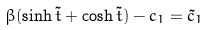<formula> <loc_0><loc_0><loc_500><loc_500>\beta ( \sinh \tilde { t } + \cosh \tilde { t } ) - c _ { 1 } = \tilde { c } _ { 1 }</formula> 